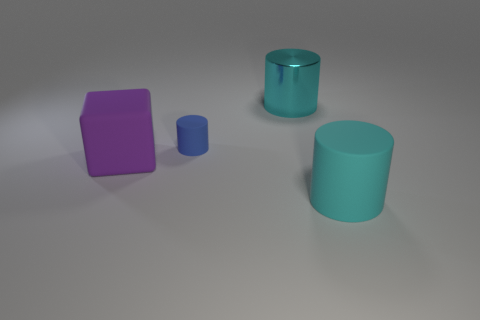Subtract all large cyan metallic cylinders. How many cylinders are left? 2 Add 1 large purple cubes. How many objects exist? 5 Subtract all cylinders. How many objects are left? 1 Add 2 small blue things. How many small blue things exist? 3 Subtract 2 cyan cylinders. How many objects are left? 2 Subtract all yellow matte cubes. Subtract all large cyan matte objects. How many objects are left? 3 Add 4 matte cylinders. How many matte cylinders are left? 6 